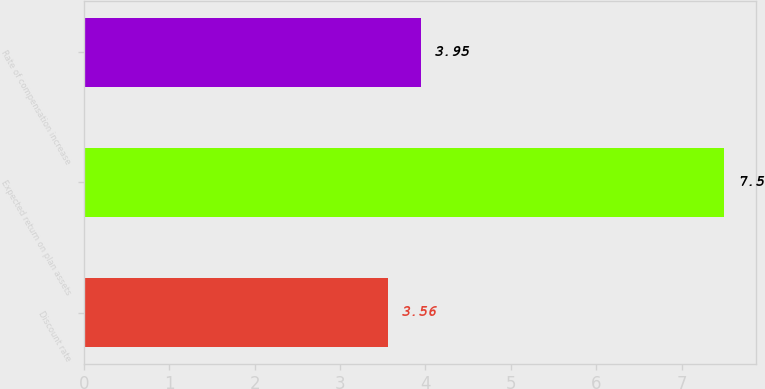Convert chart to OTSL. <chart><loc_0><loc_0><loc_500><loc_500><bar_chart><fcel>Discount rate<fcel>Expected return on plan assets<fcel>Rate of compensation increase<nl><fcel>3.56<fcel>7.5<fcel>3.95<nl></chart> 